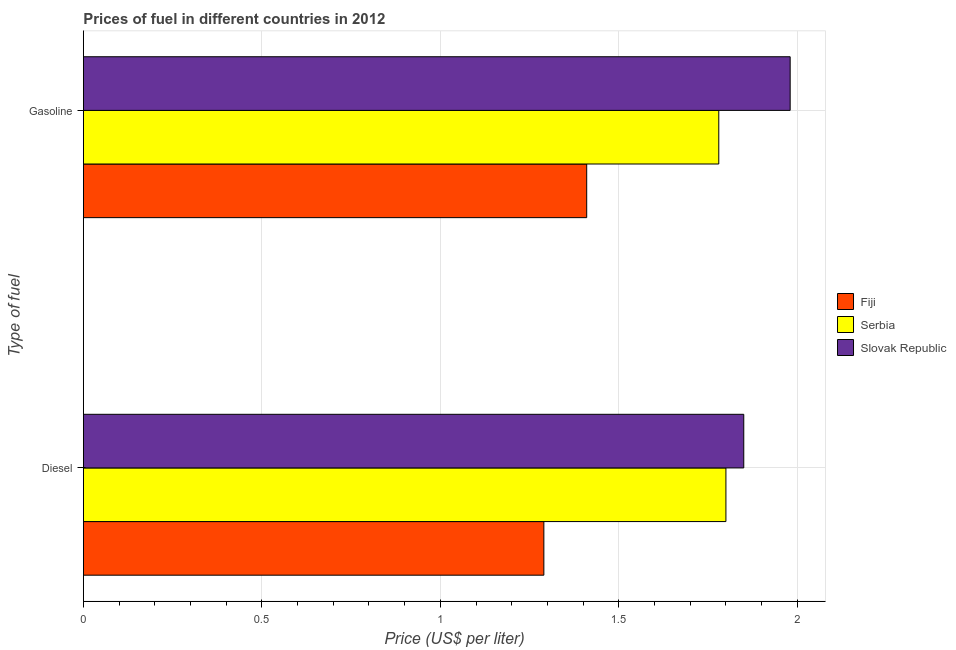Are the number of bars on each tick of the Y-axis equal?
Your answer should be compact. Yes. How many bars are there on the 1st tick from the top?
Your response must be concise. 3. What is the label of the 2nd group of bars from the top?
Your answer should be compact. Diesel. What is the gasoline price in Slovak Republic?
Give a very brief answer. 1.98. Across all countries, what is the maximum gasoline price?
Provide a succinct answer. 1.98. Across all countries, what is the minimum gasoline price?
Provide a short and direct response. 1.41. In which country was the diesel price maximum?
Provide a short and direct response. Slovak Republic. In which country was the diesel price minimum?
Offer a terse response. Fiji. What is the total gasoline price in the graph?
Provide a short and direct response. 5.17. What is the difference between the gasoline price in Slovak Republic and that in Serbia?
Your response must be concise. 0.2. What is the difference between the diesel price in Serbia and the gasoline price in Slovak Republic?
Give a very brief answer. -0.18. What is the average gasoline price per country?
Give a very brief answer. 1.72. What is the difference between the diesel price and gasoline price in Slovak Republic?
Your response must be concise. -0.13. In how many countries, is the diesel price greater than 1.1 US$ per litre?
Offer a very short reply. 3. What is the ratio of the diesel price in Serbia to that in Slovak Republic?
Offer a terse response. 0.97. Is the diesel price in Slovak Republic less than that in Serbia?
Make the answer very short. No. In how many countries, is the gasoline price greater than the average gasoline price taken over all countries?
Give a very brief answer. 2. What does the 2nd bar from the top in Gasoline represents?
Give a very brief answer. Serbia. What does the 3rd bar from the bottom in Gasoline represents?
Offer a very short reply. Slovak Republic. Are all the bars in the graph horizontal?
Provide a succinct answer. Yes. Are the values on the major ticks of X-axis written in scientific E-notation?
Provide a short and direct response. No. Where does the legend appear in the graph?
Make the answer very short. Center right. How many legend labels are there?
Keep it short and to the point. 3. How are the legend labels stacked?
Offer a terse response. Vertical. What is the title of the graph?
Your response must be concise. Prices of fuel in different countries in 2012. What is the label or title of the X-axis?
Make the answer very short. Price (US$ per liter). What is the label or title of the Y-axis?
Offer a very short reply. Type of fuel. What is the Price (US$ per liter) of Fiji in Diesel?
Give a very brief answer. 1.29. What is the Price (US$ per liter) of Serbia in Diesel?
Your answer should be very brief. 1.8. What is the Price (US$ per liter) of Slovak Republic in Diesel?
Provide a succinct answer. 1.85. What is the Price (US$ per liter) in Fiji in Gasoline?
Your response must be concise. 1.41. What is the Price (US$ per liter) in Serbia in Gasoline?
Provide a short and direct response. 1.78. What is the Price (US$ per liter) of Slovak Republic in Gasoline?
Your answer should be very brief. 1.98. Across all Type of fuel, what is the maximum Price (US$ per liter) in Fiji?
Ensure brevity in your answer.  1.41. Across all Type of fuel, what is the maximum Price (US$ per liter) of Slovak Republic?
Make the answer very short. 1.98. Across all Type of fuel, what is the minimum Price (US$ per liter) in Fiji?
Provide a short and direct response. 1.29. Across all Type of fuel, what is the minimum Price (US$ per liter) of Serbia?
Give a very brief answer. 1.78. Across all Type of fuel, what is the minimum Price (US$ per liter) of Slovak Republic?
Give a very brief answer. 1.85. What is the total Price (US$ per liter) in Serbia in the graph?
Keep it short and to the point. 3.58. What is the total Price (US$ per liter) in Slovak Republic in the graph?
Give a very brief answer. 3.83. What is the difference between the Price (US$ per liter) in Fiji in Diesel and that in Gasoline?
Provide a short and direct response. -0.12. What is the difference between the Price (US$ per liter) in Slovak Republic in Diesel and that in Gasoline?
Your response must be concise. -0.13. What is the difference between the Price (US$ per liter) of Fiji in Diesel and the Price (US$ per liter) of Serbia in Gasoline?
Provide a short and direct response. -0.49. What is the difference between the Price (US$ per liter) of Fiji in Diesel and the Price (US$ per liter) of Slovak Republic in Gasoline?
Offer a terse response. -0.69. What is the difference between the Price (US$ per liter) of Serbia in Diesel and the Price (US$ per liter) of Slovak Republic in Gasoline?
Make the answer very short. -0.18. What is the average Price (US$ per liter) in Fiji per Type of fuel?
Ensure brevity in your answer.  1.35. What is the average Price (US$ per liter) in Serbia per Type of fuel?
Offer a very short reply. 1.79. What is the average Price (US$ per liter) in Slovak Republic per Type of fuel?
Your response must be concise. 1.92. What is the difference between the Price (US$ per liter) of Fiji and Price (US$ per liter) of Serbia in Diesel?
Ensure brevity in your answer.  -0.51. What is the difference between the Price (US$ per liter) in Fiji and Price (US$ per liter) in Slovak Republic in Diesel?
Offer a very short reply. -0.56. What is the difference between the Price (US$ per liter) in Fiji and Price (US$ per liter) in Serbia in Gasoline?
Ensure brevity in your answer.  -0.37. What is the difference between the Price (US$ per liter) of Fiji and Price (US$ per liter) of Slovak Republic in Gasoline?
Your response must be concise. -0.57. What is the ratio of the Price (US$ per liter) in Fiji in Diesel to that in Gasoline?
Keep it short and to the point. 0.91. What is the ratio of the Price (US$ per liter) of Serbia in Diesel to that in Gasoline?
Ensure brevity in your answer.  1.01. What is the ratio of the Price (US$ per liter) in Slovak Republic in Diesel to that in Gasoline?
Your answer should be very brief. 0.93. What is the difference between the highest and the second highest Price (US$ per liter) of Fiji?
Ensure brevity in your answer.  0.12. What is the difference between the highest and the second highest Price (US$ per liter) of Slovak Republic?
Your answer should be compact. 0.13. What is the difference between the highest and the lowest Price (US$ per liter) in Fiji?
Keep it short and to the point. 0.12. What is the difference between the highest and the lowest Price (US$ per liter) of Serbia?
Your answer should be compact. 0.02. What is the difference between the highest and the lowest Price (US$ per liter) in Slovak Republic?
Make the answer very short. 0.13. 